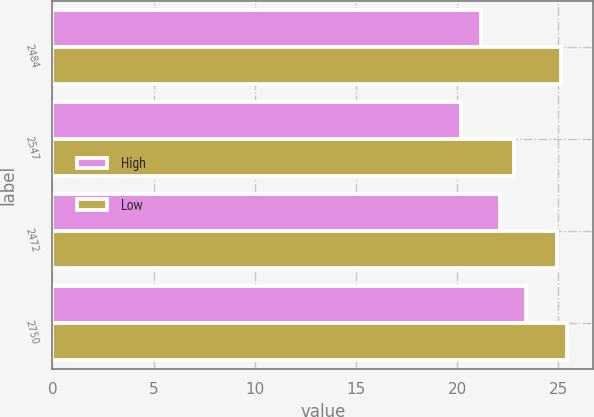Convert chart to OTSL. <chart><loc_0><loc_0><loc_500><loc_500><stacked_bar_chart><ecel><fcel>2484<fcel>2547<fcel>2472<fcel>2750<nl><fcel>High<fcel>21.17<fcel>20.21<fcel>22.13<fcel>23.4<nl><fcel>Low<fcel>25.13<fcel>22.81<fcel>24.92<fcel>25.46<nl></chart> 